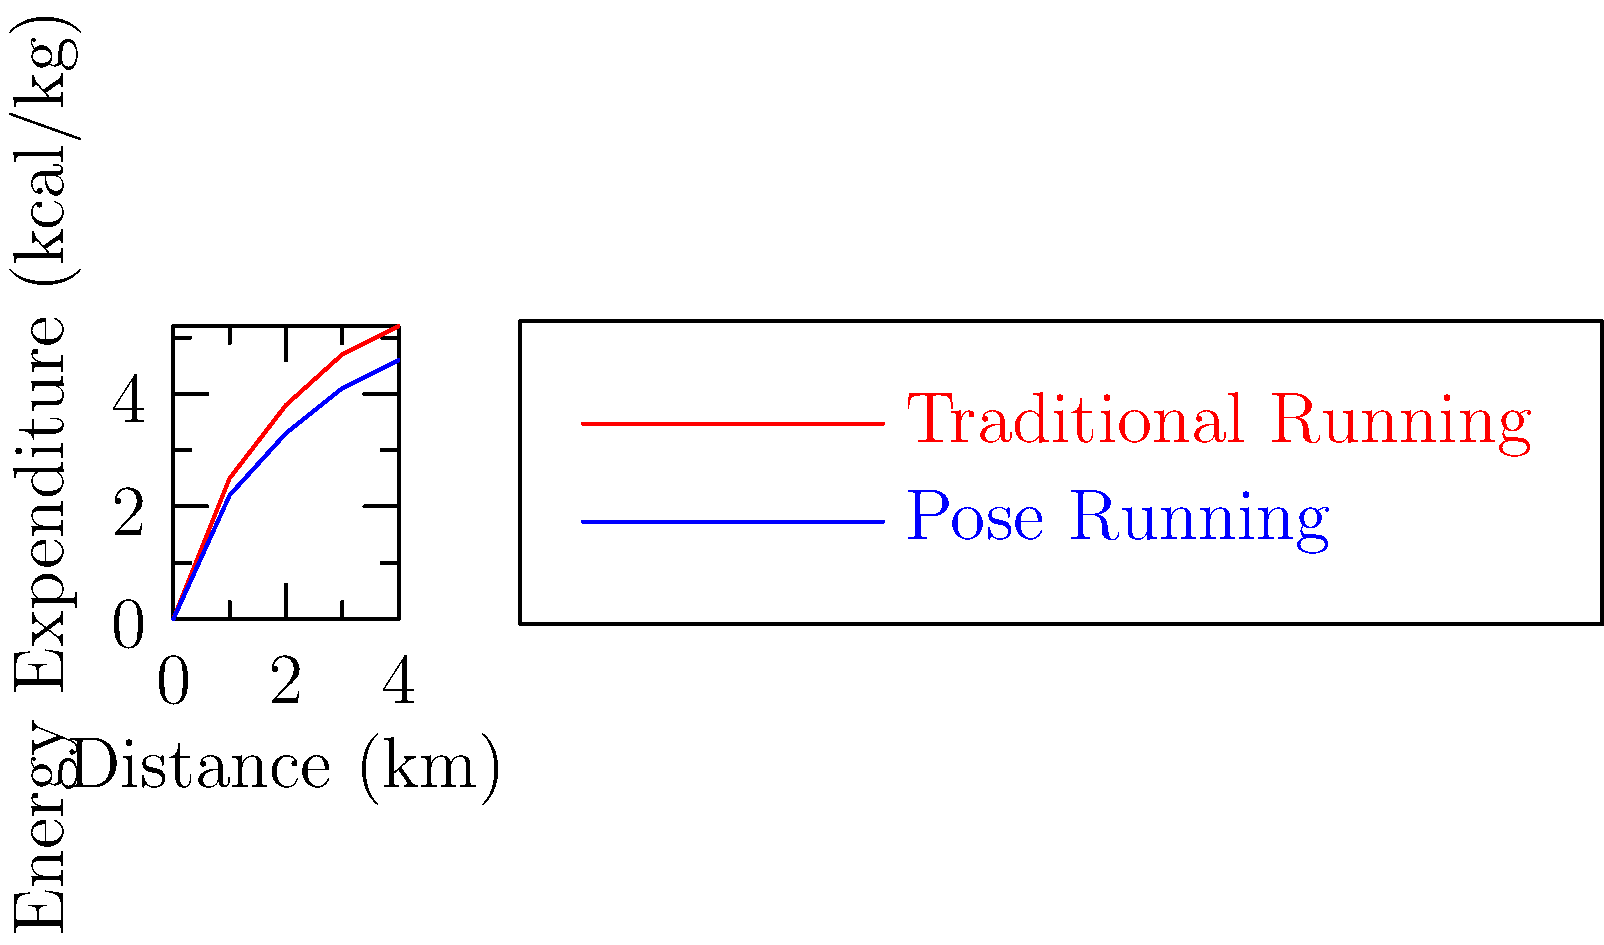Based on the graph comparing energy expenditure between traditional running and pose running techniques over a 4km distance, which method appears to be more biomechanically efficient for military fitness tests, and by approximately what percentage at the 4km mark? To determine which running technique is more biomechanically efficient and by what percentage, we'll follow these steps:

1. Identify the energy expenditure values at 4km:
   Traditional Running: 5.2 kcal/kg
   Pose Running: 4.6 kcal/kg

2. Calculate the difference in energy expenditure:
   $5.2 - 4.6 = 0.6$ kcal/kg

3. Calculate the percentage difference:
   Percentage difference = $\frac{\text{Difference}}{\text{Higher value}} \times 100\%$
   $= \frac{0.6}{5.2} \times 100\% \approx 11.54\%$

4. Determine which technique is more efficient:
   Lower energy expenditure indicates higher efficiency. Pose Running uses less energy, so it's more efficient.

Therefore, Pose Running appears to be more biomechanically efficient for military fitness tests, with approximately 11.54% less energy expenditure at the 4km mark compared to Traditional Running.
Answer: Pose Running, 11.54% more efficient 